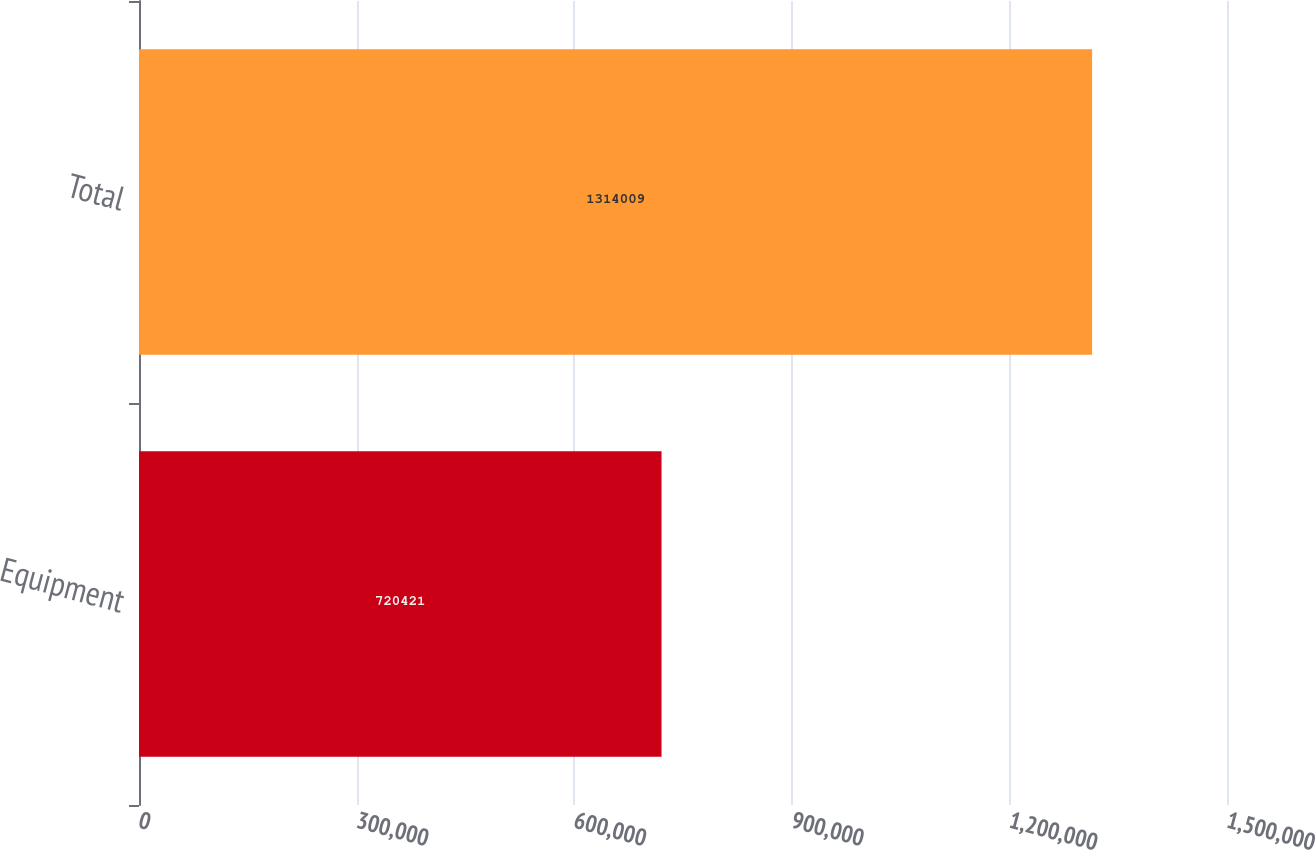Convert chart to OTSL. <chart><loc_0><loc_0><loc_500><loc_500><bar_chart><fcel>Equipment<fcel>Total<nl><fcel>720421<fcel>1.31401e+06<nl></chart> 